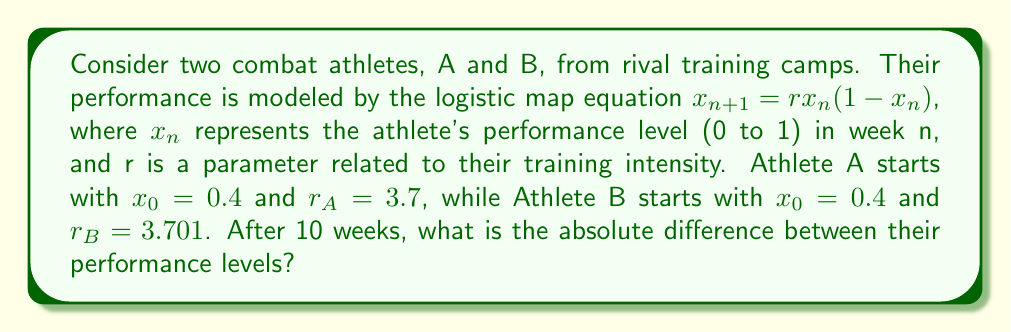Solve this math problem. To solve this problem, we need to iterate the logistic map equation for both athletes over 10 weeks:

1. For Athlete A:
   $r_A = 3.7$, $x_0 = 0.4$
   $x_1 = 3.7 * 0.4 * (1 - 0.4) = 0.888$
   $x_2 = 3.7 * 0.888 * (1 - 0.888) = 0.3682$
   ...
   $x_{10} = 0.3556$ (after 10 iterations)

2. For Athlete B:
   $r_B = 3.701$, $x_0 = 0.4$
   $x_1 = 3.701 * 0.4 * (1 - 0.4) = 0.8882$
   $x_2 = 3.701 * 0.8882 * (1 - 0.8882) = 0.3689$
   ...
   $x_{10} = 0.8134$ (after 10 iterations)

3. Calculate the absolute difference:
   $|x_{10,A} - x_{10,B}| = |0.3556 - 0.8134| = 0.4578$

This demonstrates the butterfly effect, where a small change in the training intensity (0.001 difference in r) leads to a significant difference in performance after 10 weeks.
Answer: 0.4578 